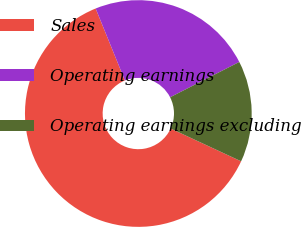<chart> <loc_0><loc_0><loc_500><loc_500><pie_chart><fcel>Sales<fcel>Operating earnings<fcel>Operating earnings excluding<nl><fcel>61.93%<fcel>23.63%<fcel>14.44%<nl></chart> 